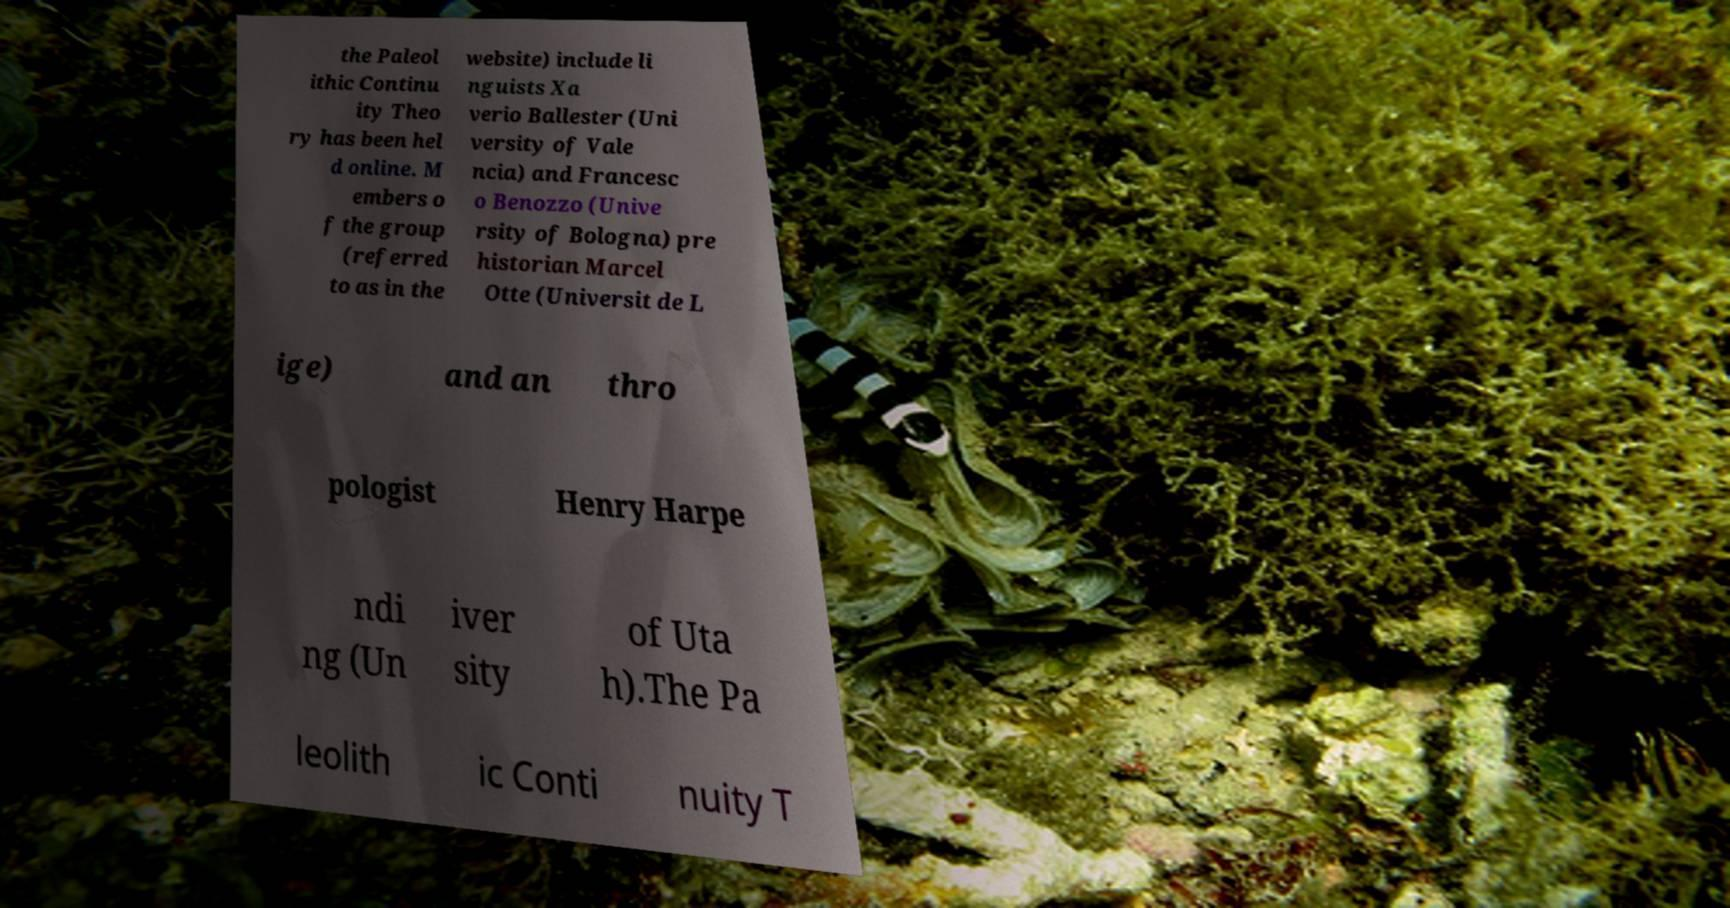Please identify and transcribe the text found in this image. the Paleol ithic Continu ity Theo ry has been hel d online. M embers o f the group (referred to as in the website) include li nguists Xa verio Ballester (Uni versity of Vale ncia) and Francesc o Benozzo (Unive rsity of Bologna) pre historian Marcel Otte (Universit de L ige) and an thro pologist Henry Harpe ndi ng (Un iver sity of Uta h).The Pa leolith ic Conti nuity T 